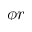<formula> <loc_0><loc_0><loc_500><loc_500>\phi r</formula> 